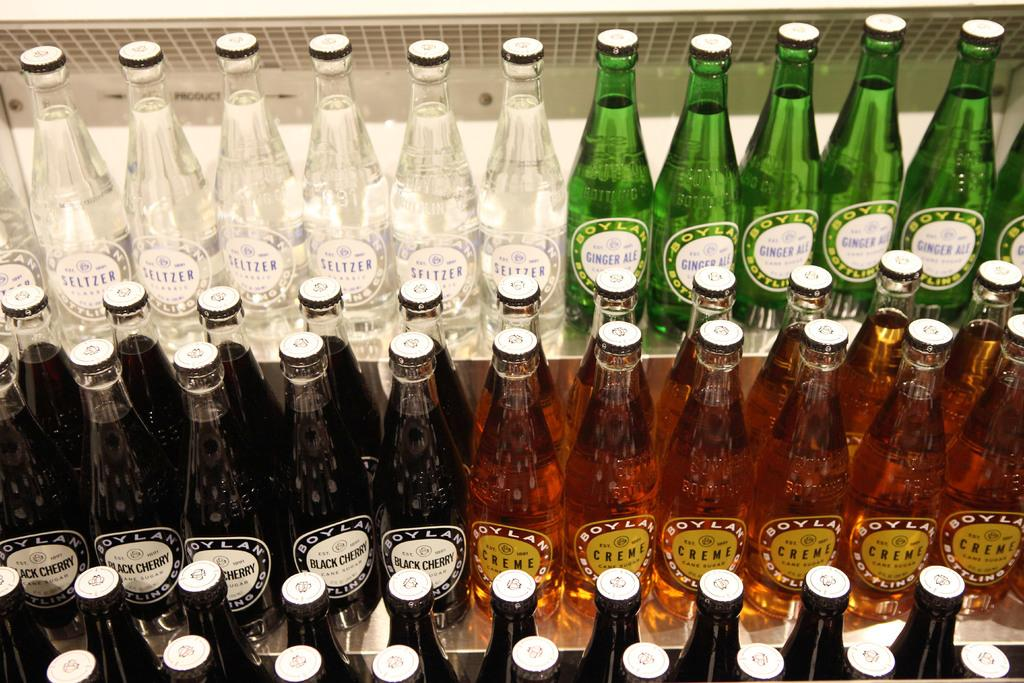Provide a one-sentence caption for the provided image. Green bottles of Ginger ale next to some white bottles. 